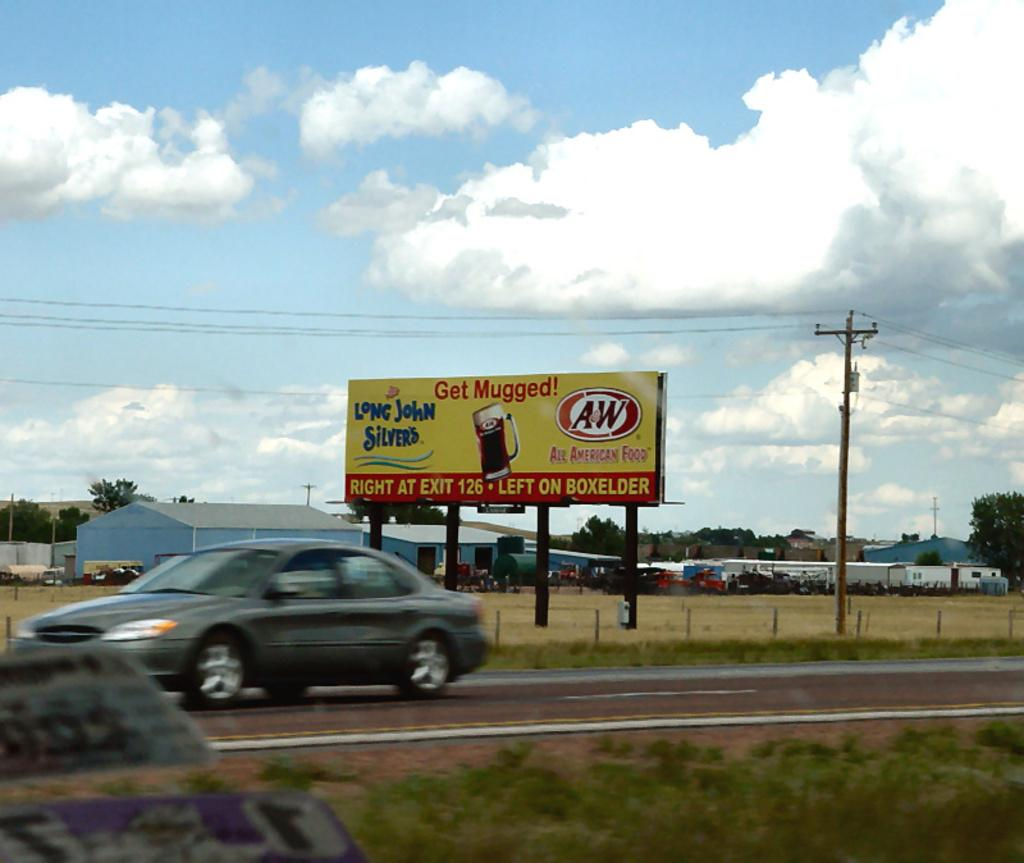<image>
Describe the image concisely. Car driving in front of a yellow sign that says GET MUGGED. 